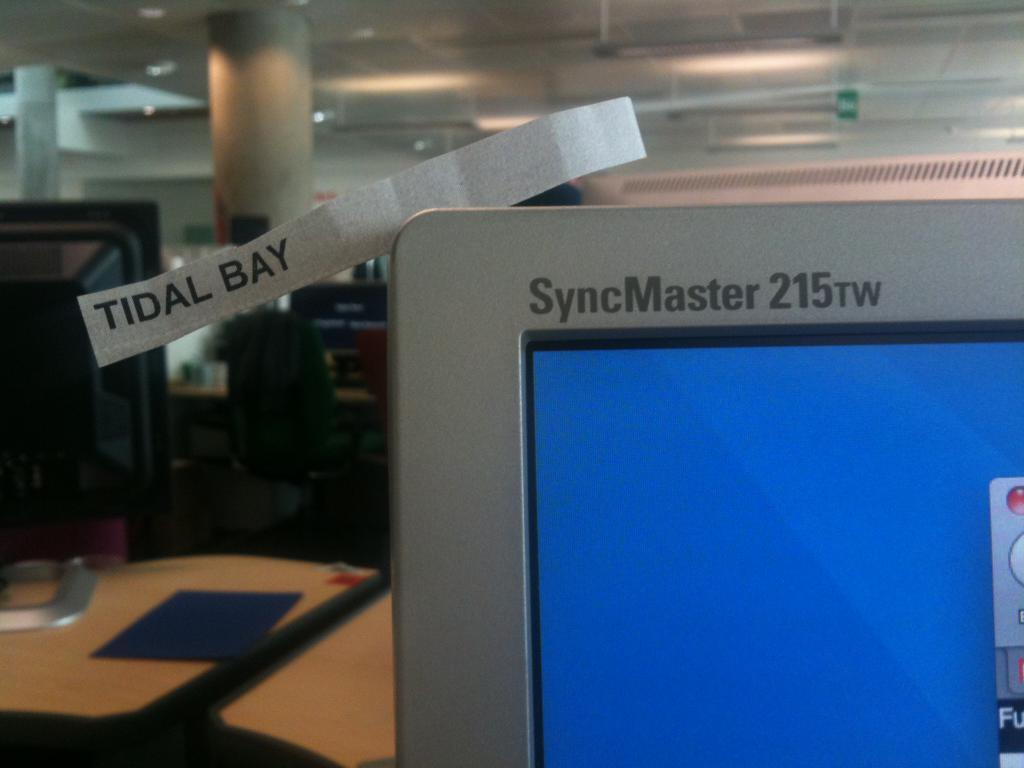<image>
Create a compact narrative representing the image presented. a computer with the name syncmaster 215rw on it 